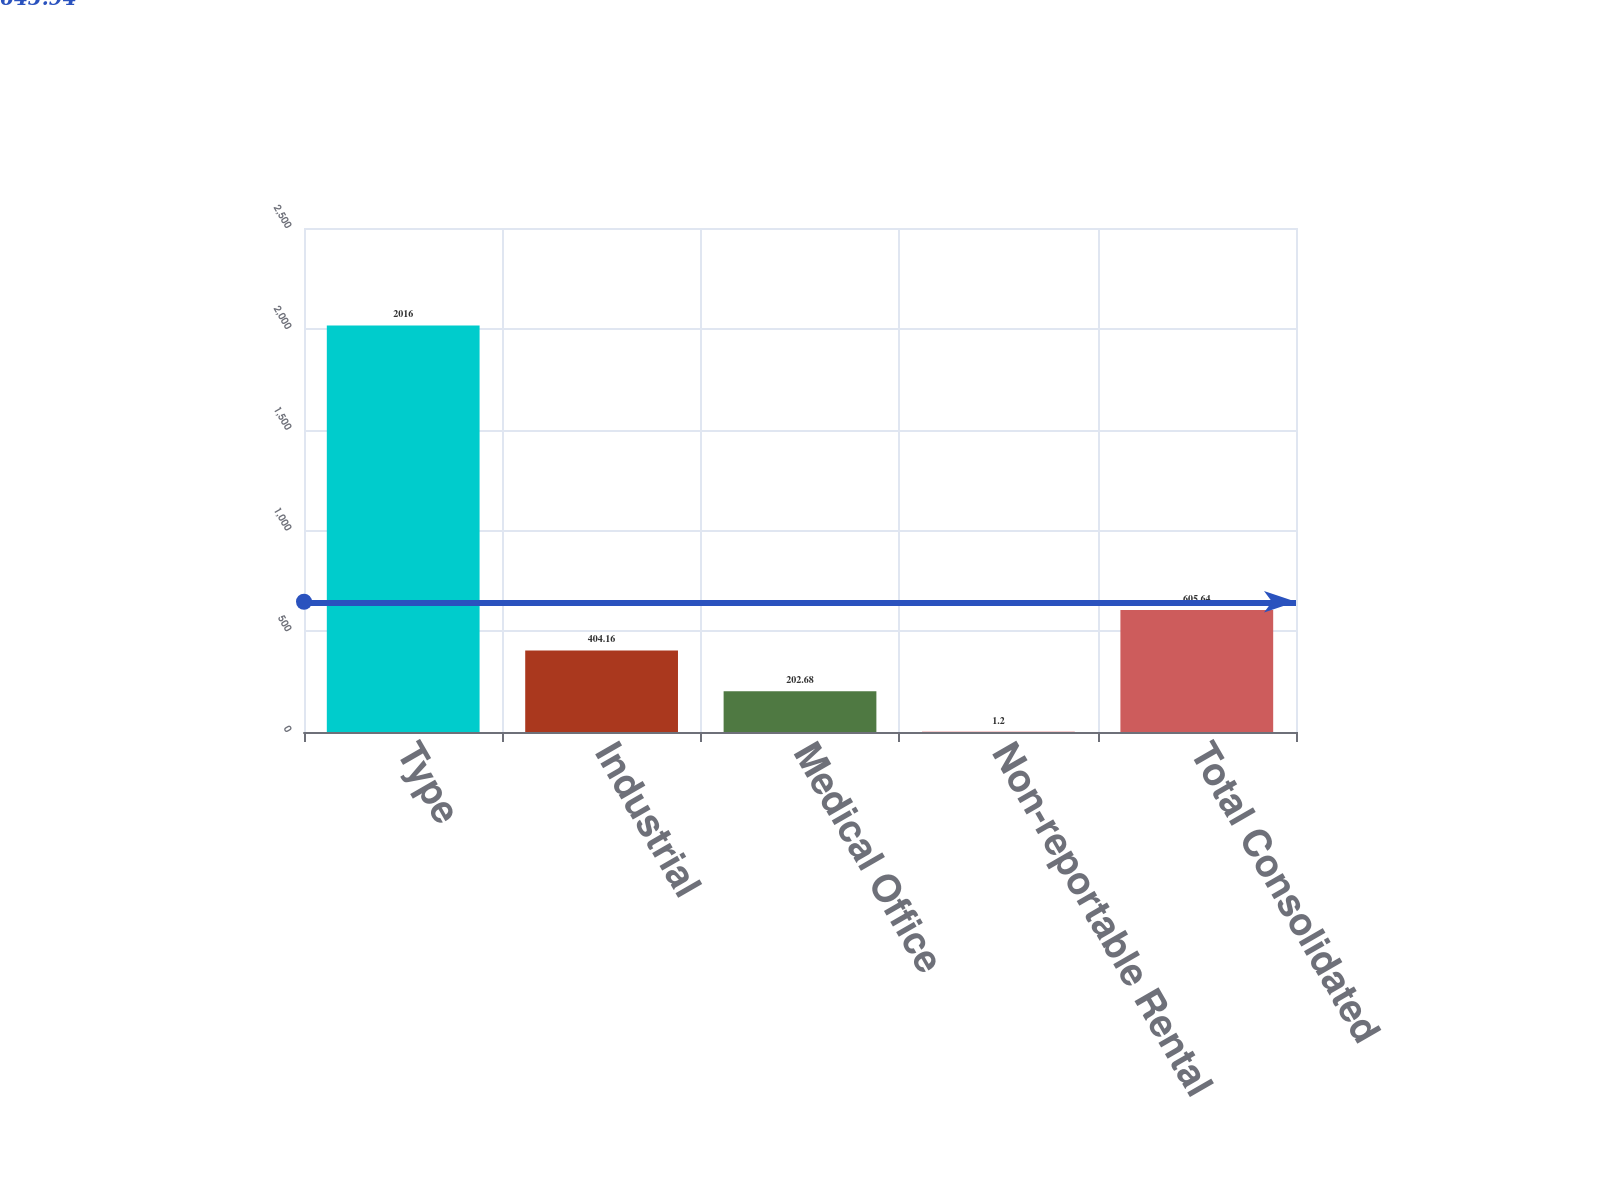<chart> <loc_0><loc_0><loc_500><loc_500><bar_chart><fcel>Type<fcel>Industrial<fcel>Medical Office<fcel>Non-reportable Rental<fcel>Total Consolidated<nl><fcel>2016<fcel>404.16<fcel>202.68<fcel>1.2<fcel>605.64<nl></chart> 